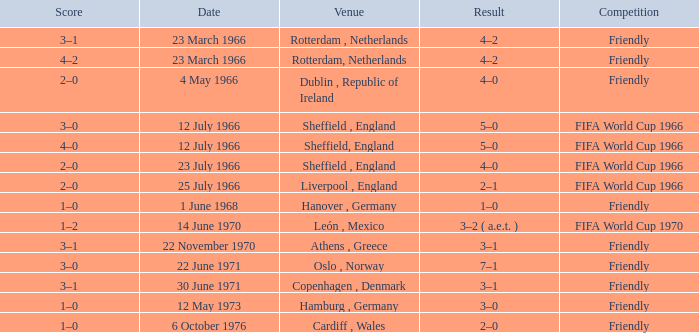Which result's venue was in Rotterdam, Netherlands? 4–2, 4–2. 